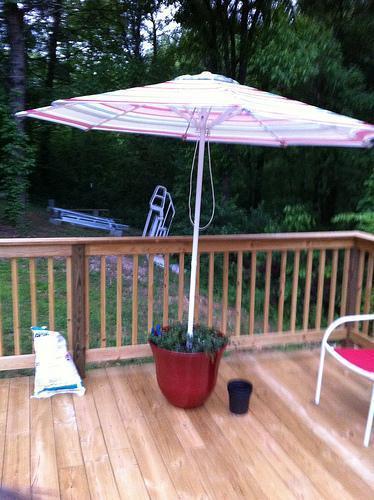How many umbrellas?
Give a very brief answer. 1. 